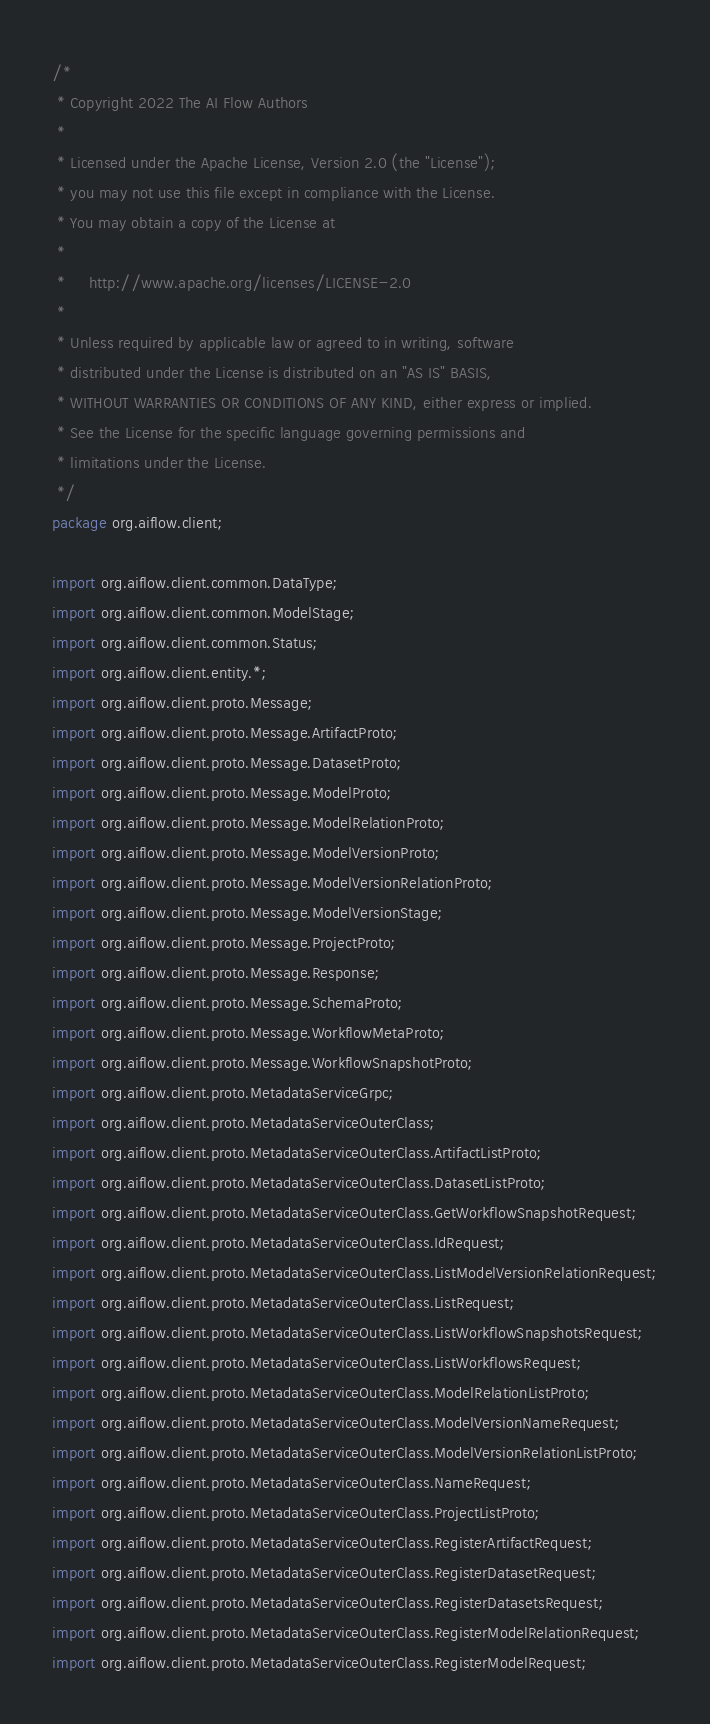Convert code to text. <code><loc_0><loc_0><loc_500><loc_500><_Java_>/*
 * Copyright 2022 The AI Flow Authors
 *
 * Licensed under the Apache License, Version 2.0 (the "License");
 * you may not use this file except in compliance with the License.
 * You may obtain a copy of the License at
 *
 *     http://www.apache.org/licenses/LICENSE-2.0
 *
 * Unless required by applicable law or agreed to in writing, software
 * distributed under the License is distributed on an "AS IS" BASIS,
 * WITHOUT WARRANTIES OR CONDITIONS OF ANY KIND, either express or implied.
 * See the License for the specific language governing permissions and
 * limitations under the License.
 */
package org.aiflow.client;

import org.aiflow.client.common.DataType;
import org.aiflow.client.common.ModelStage;
import org.aiflow.client.common.Status;
import org.aiflow.client.entity.*;
import org.aiflow.client.proto.Message;
import org.aiflow.client.proto.Message.ArtifactProto;
import org.aiflow.client.proto.Message.DatasetProto;
import org.aiflow.client.proto.Message.ModelProto;
import org.aiflow.client.proto.Message.ModelRelationProto;
import org.aiflow.client.proto.Message.ModelVersionProto;
import org.aiflow.client.proto.Message.ModelVersionRelationProto;
import org.aiflow.client.proto.Message.ModelVersionStage;
import org.aiflow.client.proto.Message.ProjectProto;
import org.aiflow.client.proto.Message.Response;
import org.aiflow.client.proto.Message.SchemaProto;
import org.aiflow.client.proto.Message.WorkflowMetaProto;
import org.aiflow.client.proto.Message.WorkflowSnapshotProto;
import org.aiflow.client.proto.MetadataServiceGrpc;
import org.aiflow.client.proto.MetadataServiceOuterClass;
import org.aiflow.client.proto.MetadataServiceOuterClass.ArtifactListProto;
import org.aiflow.client.proto.MetadataServiceOuterClass.DatasetListProto;
import org.aiflow.client.proto.MetadataServiceOuterClass.GetWorkflowSnapshotRequest;
import org.aiflow.client.proto.MetadataServiceOuterClass.IdRequest;
import org.aiflow.client.proto.MetadataServiceOuterClass.ListModelVersionRelationRequest;
import org.aiflow.client.proto.MetadataServiceOuterClass.ListRequest;
import org.aiflow.client.proto.MetadataServiceOuterClass.ListWorkflowSnapshotsRequest;
import org.aiflow.client.proto.MetadataServiceOuterClass.ListWorkflowsRequest;
import org.aiflow.client.proto.MetadataServiceOuterClass.ModelRelationListProto;
import org.aiflow.client.proto.MetadataServiceOuterClass.ModelVersionNameRequest;
import org.aiflow.client.proto.MetadataServiceOuterClass.ModelVersionRelationListProto;
import org.aiflow.client.proto.MetadataServiceOuterClass.NameRequest;
import org.aiflow.client.proto.MetadataServiceOuterClass.ProjectListProto;
import org.aiflow.client.proto.MetadataServiceOuterClass.RegisterArtifactRequest;
import org.aiflow.client.proto.MetadataServiceOuterClass.RegisterDatasetRequest;
import org.aiflow.client.proto.MetadataServiceOuterClass.RegisterDatasetsRequest;
import org.aiflow.client.proto.MetadataServiceOuterClass.RegisterModelRelationRequest;
import org.aiflow.client.proto.MetadataServiceOuterClass.RegisterModelRequest;</code> 